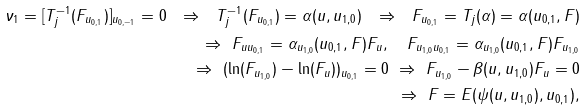<formula> <loc_0><loc_0><loc_500><loc_500>\nu _ { 1 } = [ T _ { j } ^ { - 1 } ( F _ { u _ { 0 , 1 } } ) ] _ { u _ { 0 , - 1 } } = 0 \ \Rightarrow \ T _ { j } ^ { - 1 } ( F _ { u _ { 0 , 1 } } ) = \alpha ( u , u _ { 1 , 0 } ) \ \Rightarrow \ F _ { u _ { 0 , 1 } } = T _ { j } ( \alpha ) = \alpha ( u _ { 0 , 1 } , F ) \\ \quad \Rightarrow \ F _ { u u _ { 0 , 1 } } = \alpha _ { u _ { 1 , 0 } } ( u _ { 0 , 1 } , F ) F _ { u } , \quad F _ { u _ { 1 , 0 } u _ { 0 , 1 } } = \alpha _ { u _ { 1 , 0 } } ( u _ { 0 , 1 } , F ) F _ { u _ { 1 , 0 } } \\ \quad \Rightarrow \ ( \ln ( F _ { u _ { 1 , 0 } } ) - \ln ( F _ { u } ) ) _ { u _ { 0 , 1 } } = 0 \ \Rightarrow \ F _ { u _ { 1 , 0 } } - \beta ( u , u _ { 1 , 0 } ) F _ { u } = 0 \\ \quad \Rightarrow \ F = E ( \psi ( u , u _ { 1 , 0 } ) , u _ { 0 , 1 } ) ,</formula> 